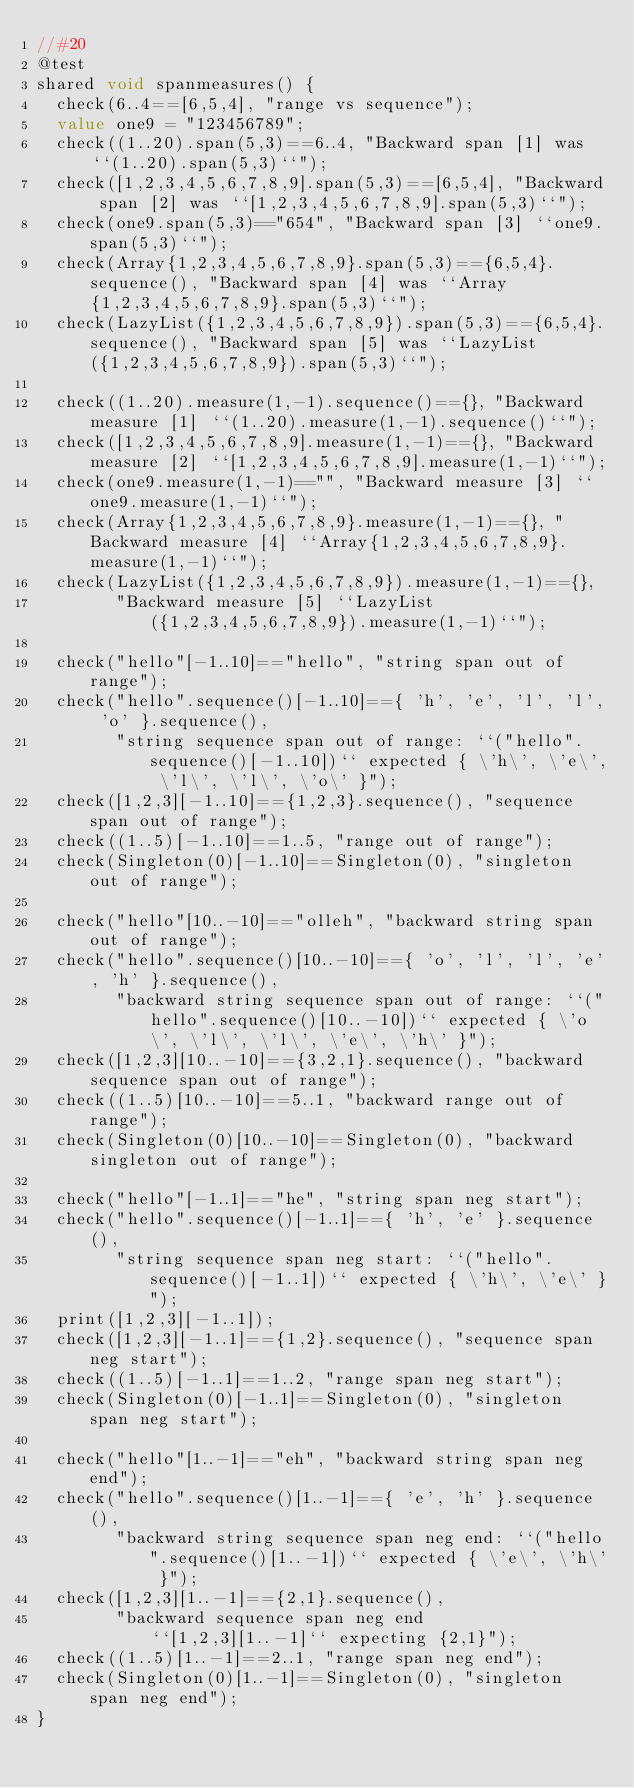<code> <loc_0><loc_0><loc_500><loc_500><_Ceylon_>//#20
@test
shared void spanmeasures() {
  check(6..4==[6,5,4], "range vs sequence");
  value one9 = "123456789";
  check((1..20).span(5,3)==6..4, "Backward span [1] was ``(1..20).span(5,3)``");
  check([1,2,3,4,5,6,7,8,9].span(5,3)==[6,5,4], "Backward span [2] was ``[1,2,3,4,5,6,7,8,9].span(5,3)``");
  check(one9.span(5,3)=="654", "Backward span [3] ``one9.span(5,3)``");
  check(Array{1,2,3,4,5,6,7,8,9}.span(5,3)=={6,5,4}.sequence(), "Backward span [4] was ``Array{1,2,3,4,5,6,7,8,9}.span(5,3)``");
  check(LazyList({1,2,3,4,5,6,7,8,9}).span(5,3)=={6,5,4}.sequence(), "Backward span [5] was ``LazyList({1,2,3,4,5,6,7,8,9}).span(5,3)``");

  check((1..20).measure(1,-1).sequence()=={}, "Backward measure [1] ``(1..20).measure(1,-1).sequence()``");
  check([1,2,3,4,5,6,7,8,9].measure(1,-1)=={}, "Backward measure [2] ``[1,2,3,4,5,6,7,8,9].measure(1,-1)``");
  check(one9.measure(1,-1)=="", "Backward measure [3] ``one9.measure(1,-1)``");
  check(Array{1,2,3,4,5,6,7,8,9}.measure(1,-1)=={}, "Backward measure [4] ``Array{1,2,3,4,5,6,7,8,9}.measure(1,-1)``");
  check(LazyList({1,2,3,4,5,6,7,8,9}).measure(1,-1)=={},
        "Backward measure [5] ``LazyList({1,2,3,4,5,6,7,8,9}).measure(1,-1)``");

  check("hello"[-1..10]=="hello", "string span out of range");
  check("hello".sequence()[-1..10]=={ 'h', 'e', 'l', 'l', 'o' }.sequence(), 
        "string sequence span out of range: ``("hello".sequence()[-1..10])`` expected { \'h\', \'e\', \'l\', \'l\', \'o\' }");
  check([1,2,3][-1..10]=={1,2,3}.sequence(), "sequence span out of range");
  check((1..5)[-1..10]==1..5, "range out of range");
  check(Singleton(0)[-1..10]==Singleton(0), "singleton out of range");
    
  check("hello"[10..-10]=="olleh", "backward string span out of range");
  check("hello".sequence()[10..-10]=={ 'o', 'l', 'l', 'e', 'h' }.sequence(), 
        "backward string sequence span out of range: ``("hello".sequence()[10..-10])`` expected { \'o\', \'l\', \'l\', \'e\', \'h\' }");
  check([1,2,3][10..-10]=={3,2,1}.sequence(), "backward sequence span out of range");
  check((1..5)[10..-10]==5..1, "backward range out of range");
  check(Singleton(0)[10..-10]==Singleton(0), "backward singleton out of range");
  
  check("hello"[-1..1]=="he", "string span neg start");
  check("hello".sequence()[-1..1]=={ 'h', 'e' }.sequence(),
        "string sequence span neg start: ``("hello".sequence()[-1..1])`` expected { \'h\', \'e\' }");
  print([1,2,3][-1..1]);
  check([1,2,3][-1..1]=={1,2}.sequence(), "sequence span neg start");
  check((1..5)[-1..1]==1..2, "range span neg start");
  check(Singleton(0)[-1..1]==Singleton(0), "singleton span neg start");
  
  check("hello"[1..-1]=="eh", "backward string span neg end");
  check("hello".sequence()[1..-1]=={ 'e', 'h' }.sequence(),
        "backward string sequence span neg end: ``("hello".sequence()[1..-1])`` expected { \'e\', \'h\' }");
  check([1,2,3][1..-1]=={2,1}.sequence(),
        "backward sequence span neg end ``[1,2,3][1..-1]`` expecting {2,1}");
  check((1..5)[1..-1]==2..1, "range span neg end");
  check(Singleton(0)[1..-1]==Singleton(0), "singleton span neg end");
}
</code> 